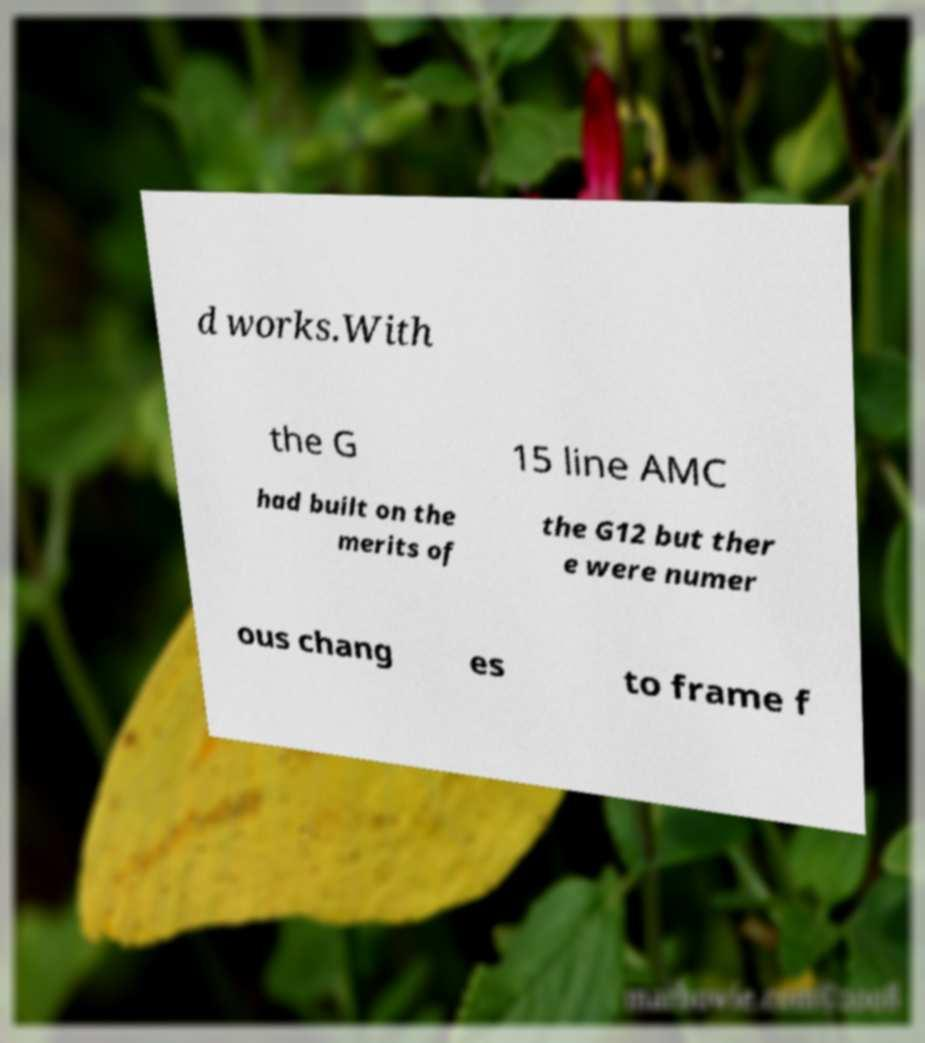Could you assist in decoding the text presented in this image and type it out clearly? d works.With the G 15 line AMC had built on the merits of the G12 but ther e were numer ous chang es to frame f 